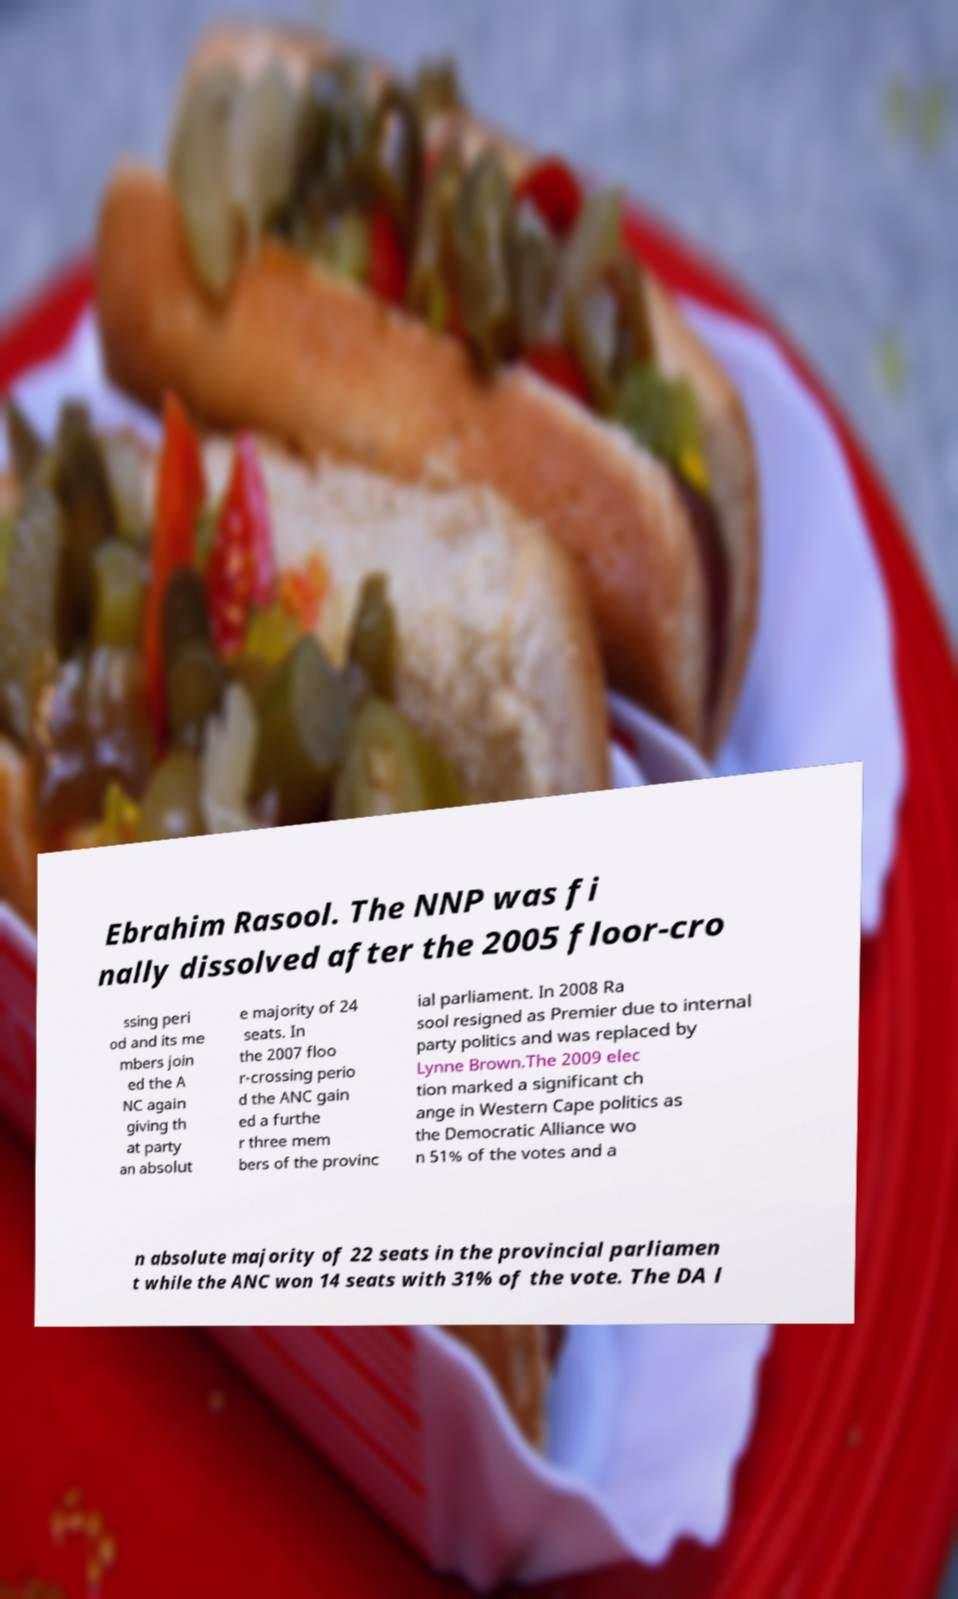What messages or text are displayed in this image? I need them in a readable, typed format. Ebrahim Rasool. The NNP was fi nally dissolved after the 2005 floor-cro ssing peri od and its me mbers join ed the A NC again giving th at party an absolut e majority of 24 seats. In the 2007 floo r-crossing perio d the ANC gain ed a furthe r three mem bers of the provinc ial parliament. In 2008 Ra sool resigned as Premier due to internal party politics and was replaced by Lynne Brown.The 2009 elec tion marked a significant ch ange in Western Cape politics as the Democratic Alliance wo n 51% of the votes and a n absolute majority of 22 seats in the provincial parliamen t while the ANC won 14 seats with 31% of the vote. The DA l 